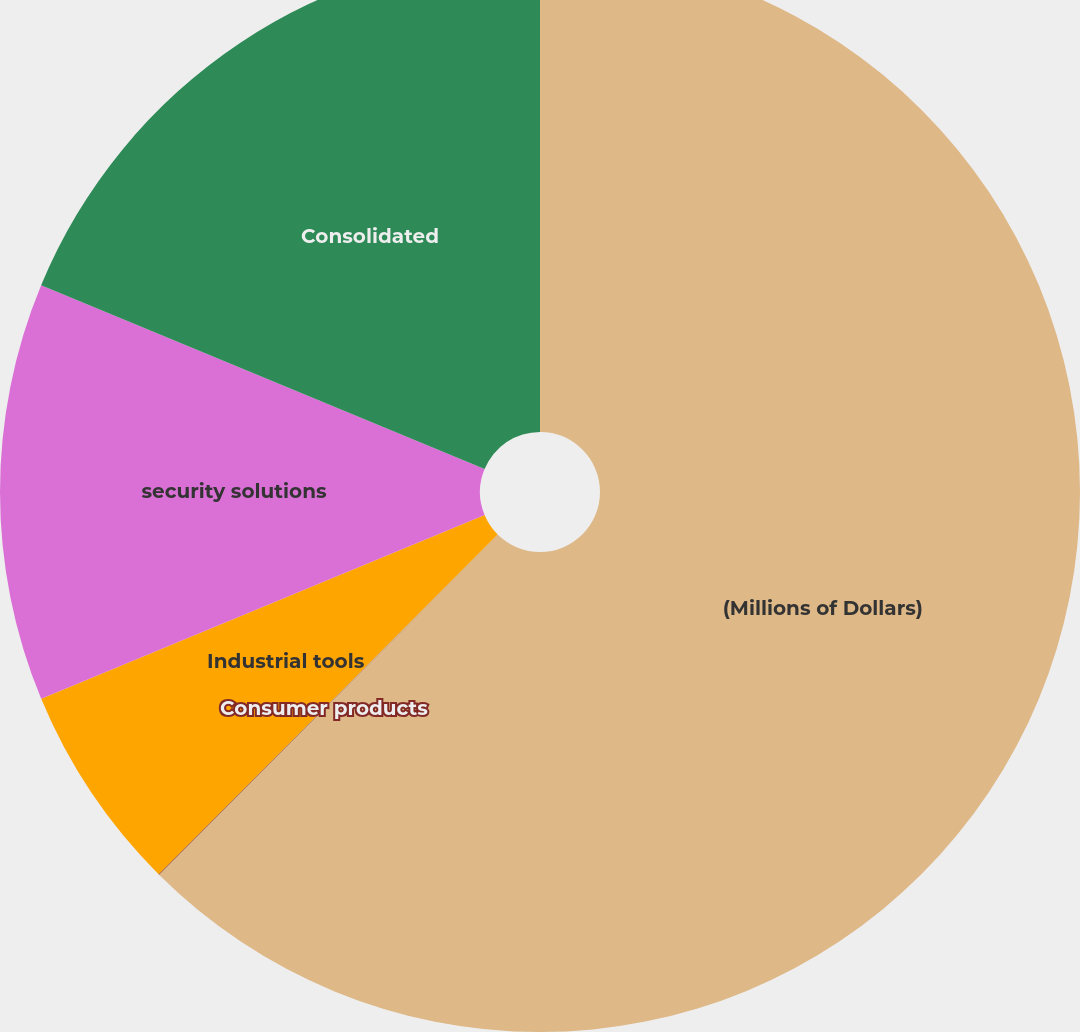Convert chart. <chart><loc_0><loc_0><loc_500><loc_500><pie_chart><fcel>(Millions of Dollars)<fcel>Consumer products<fcel>Industrial tools<fcel>security solutions<fcel>Consolidated<nl><fcel>62.47%<fcel>0.02%<fcel>6.26%<fcel>12.51%<fcel>18.75%<nl></chart> 